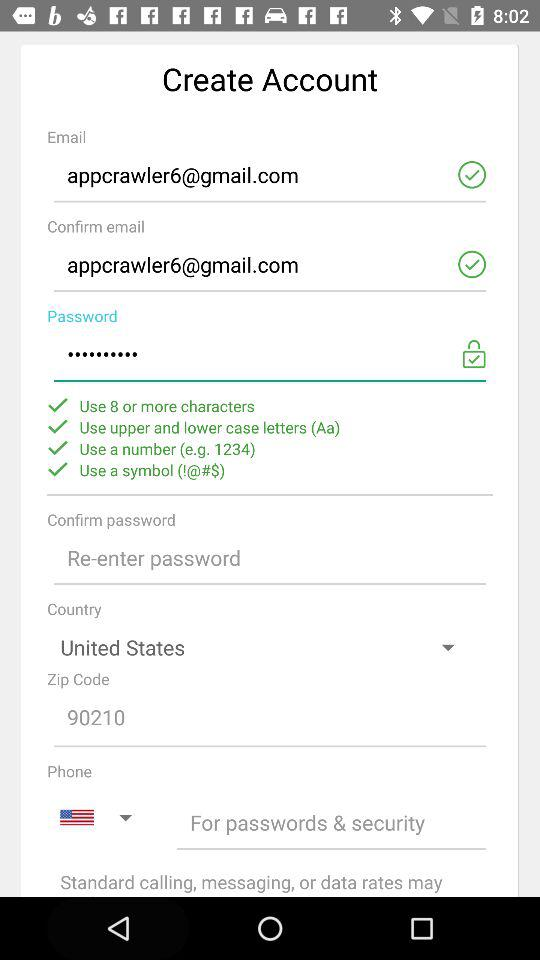What is the name of the country? The name of the country is the United States. 